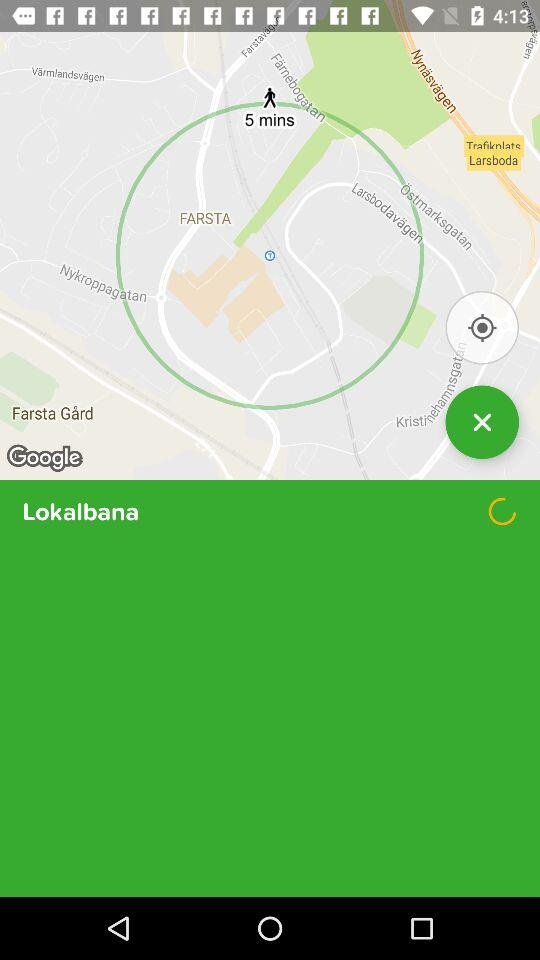Where is the given location?
When the provided information is insufficient, respond with <no answer>. <no answer> 